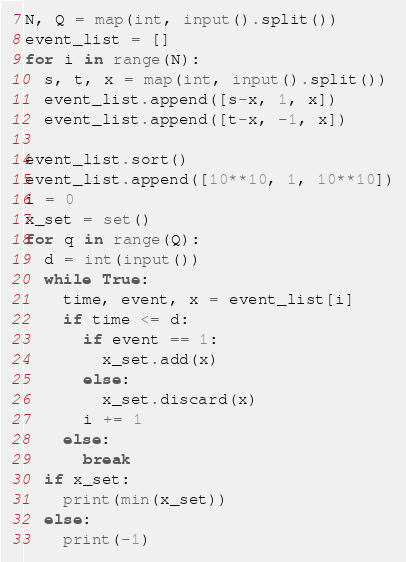<code> <loc_0><loc_0><loc_500><loc_500><_Python_>N, Q = map(int, input().split())
event_list = []
for i in range(N):
  s, t, x = map(int, input().split())
  event_list.append([s-x, 1, x])
  event_list.append([t-x, -1, x])

event_list.sort()
event_list.append([10**10, 1, 10**10])
i = 0
x_set = set()
for q in range(Q):
  d = int(input())
  while True:
    time, event, x = event_list[i]
    if time <= d:
      if event == 1:
        x_set.add(x)
      else:
        x_set.discard(x)
      i += 1
    else:
      break
  if x_set:
    print(min(x_set))
  else:
    print(-1)</code> 